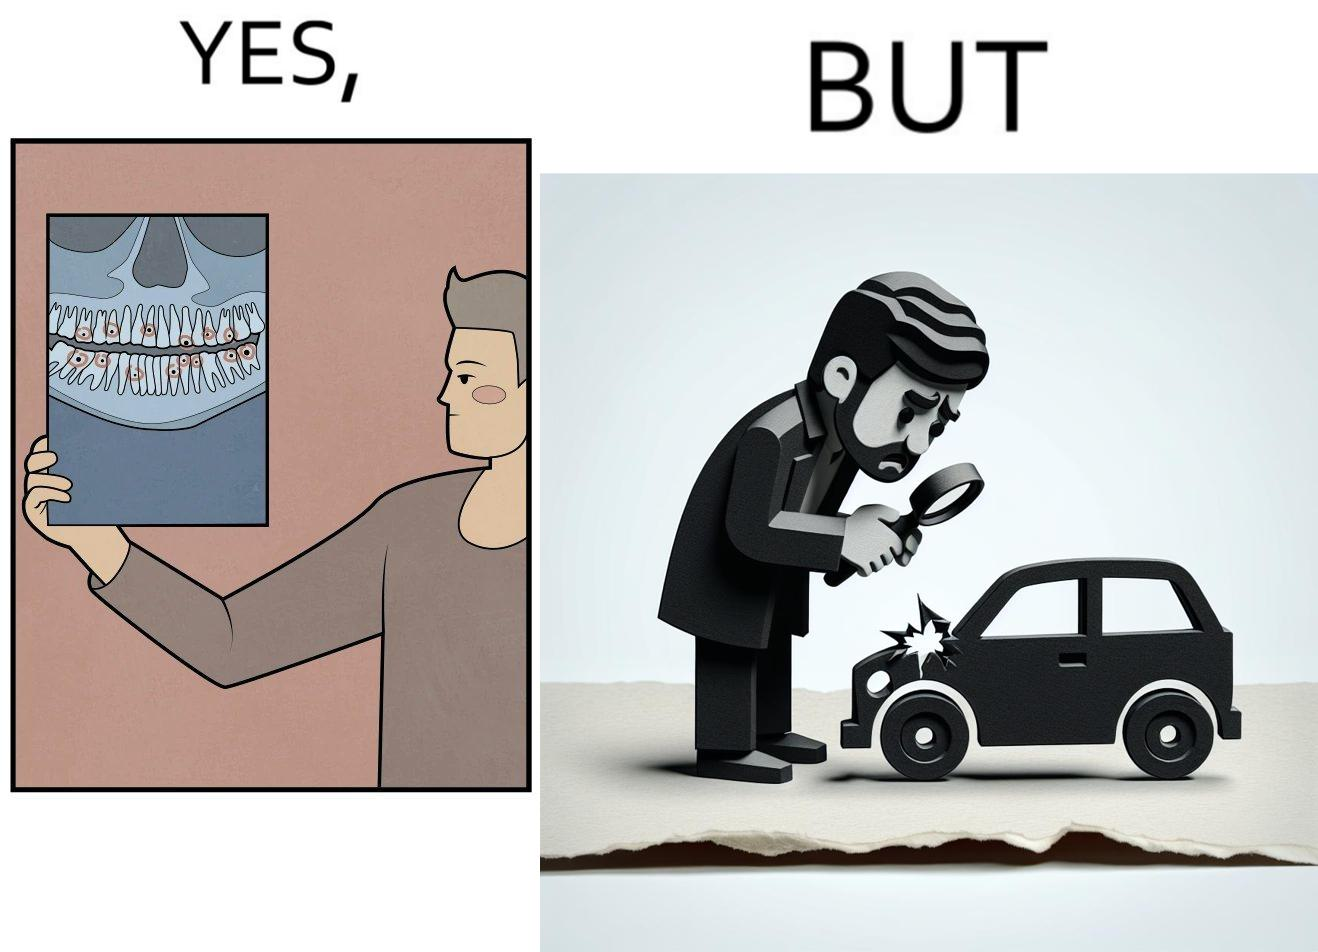Would you classify this image as satirical? Yes, this image is satirical. 